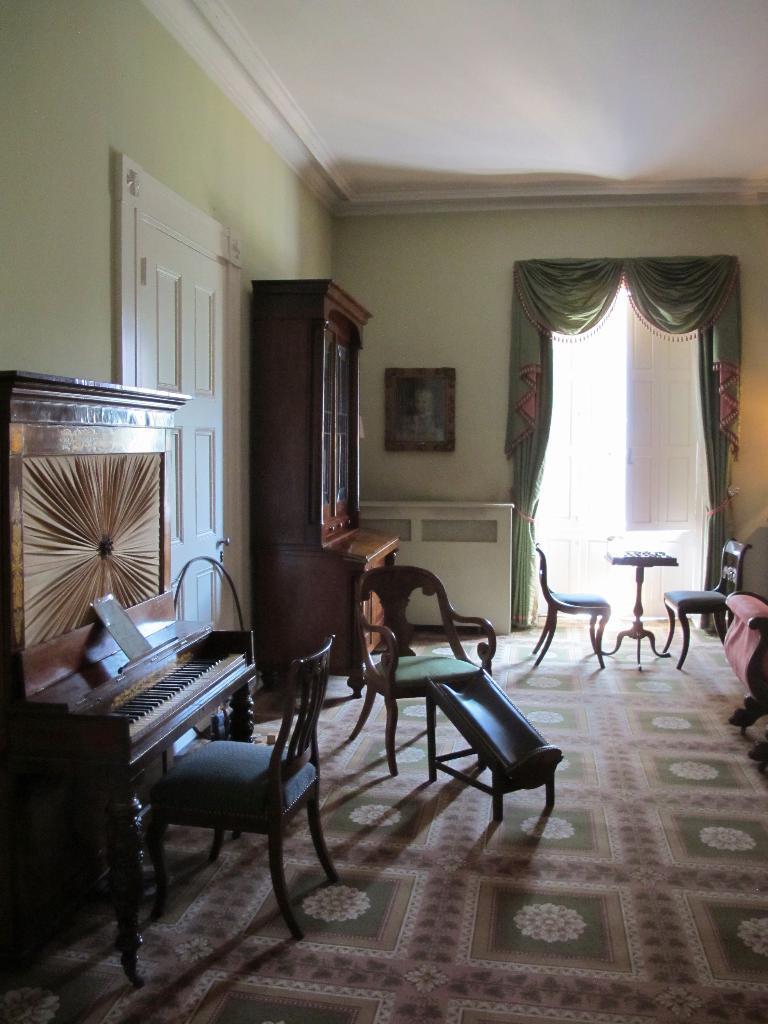Please provide a concise description of this image. This picture is taken in a room, there is a green color carpet and there are some chairs which are in brown color, there is a piano which in brown color, there is a white color door, there is a brown color object, in the left side there is a yellow color wall and there is a green color curtain. 